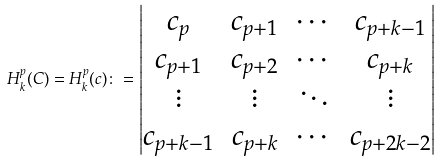Convert formula to latex. <formula><loc_0><loc_0><loc_500><loc_500>H _ { k } ^ { p } ( C ) = H _ { k } ^ { p } ( { c } ) \colon = \begin{vmatrix} c _ { p } & c _ { p + 1 } & \cdots & c _ { p + k - 1 } \\ c _ { p + 1 } & c _ { p + 2 } & \cdots & c _ { p + k } \\ \vdots & \vdots & \ddots & \vdots \\ c _ { p + k - 1 } & c _ { p + k } & \cdots & c _ { p + 2 k - 2 } \end{vmatrix}</formula> 